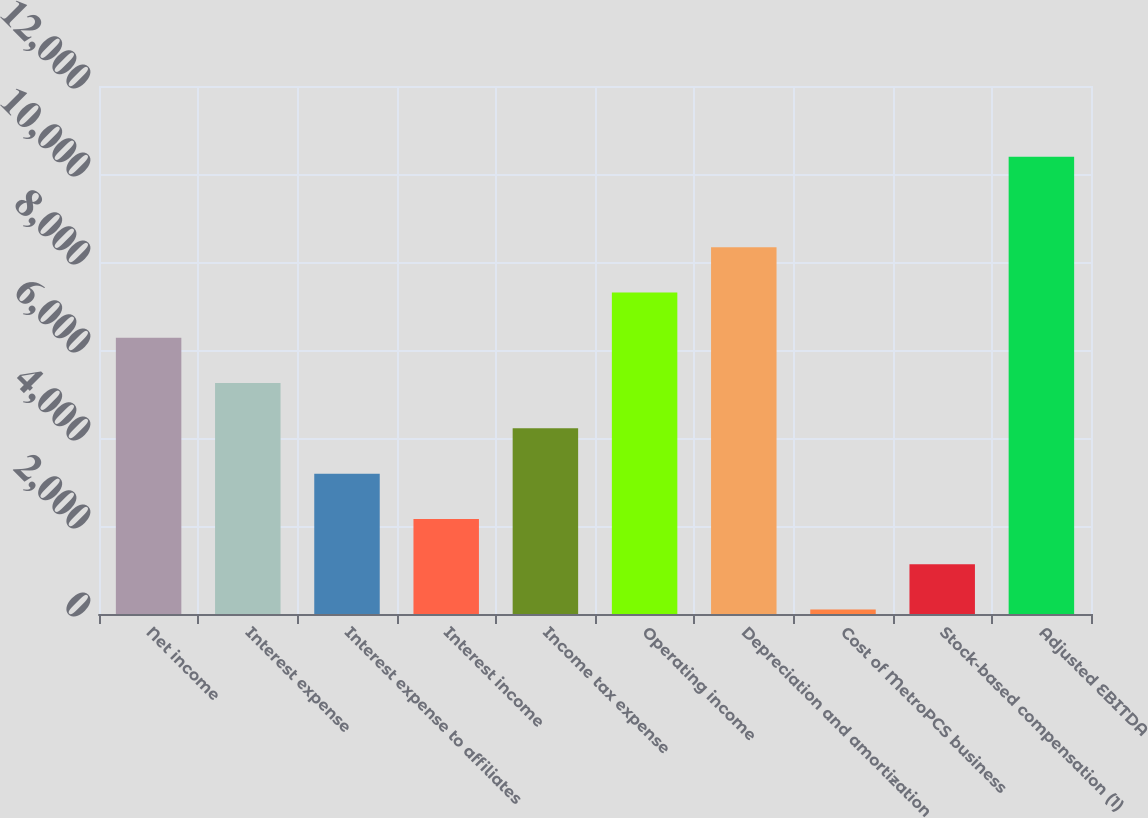Convert chart. <chart><loc_0><loc_0><loc_500><loc_500><bar_chart><fcel>Net income<fcel>Interest expense<fcel>Interest expense to affiliates<fcel>Interest income<fcel>Income tax expense<fcel>Operating income<fcel>Depreciation and amortization<fcel>Cost of MetroPCS business<fcel>Stock-based compensation (1)<fcel>Adjusted EBITDA<nl><fcel>6276.2<fcel>5247.5<fcel>3190.1<fcel>2161.4<fcel>4218.8<fcel>7304.9<fcel>8333.6<fcel>104<fcel>1132.7<fcel>10391<nl></chart> 